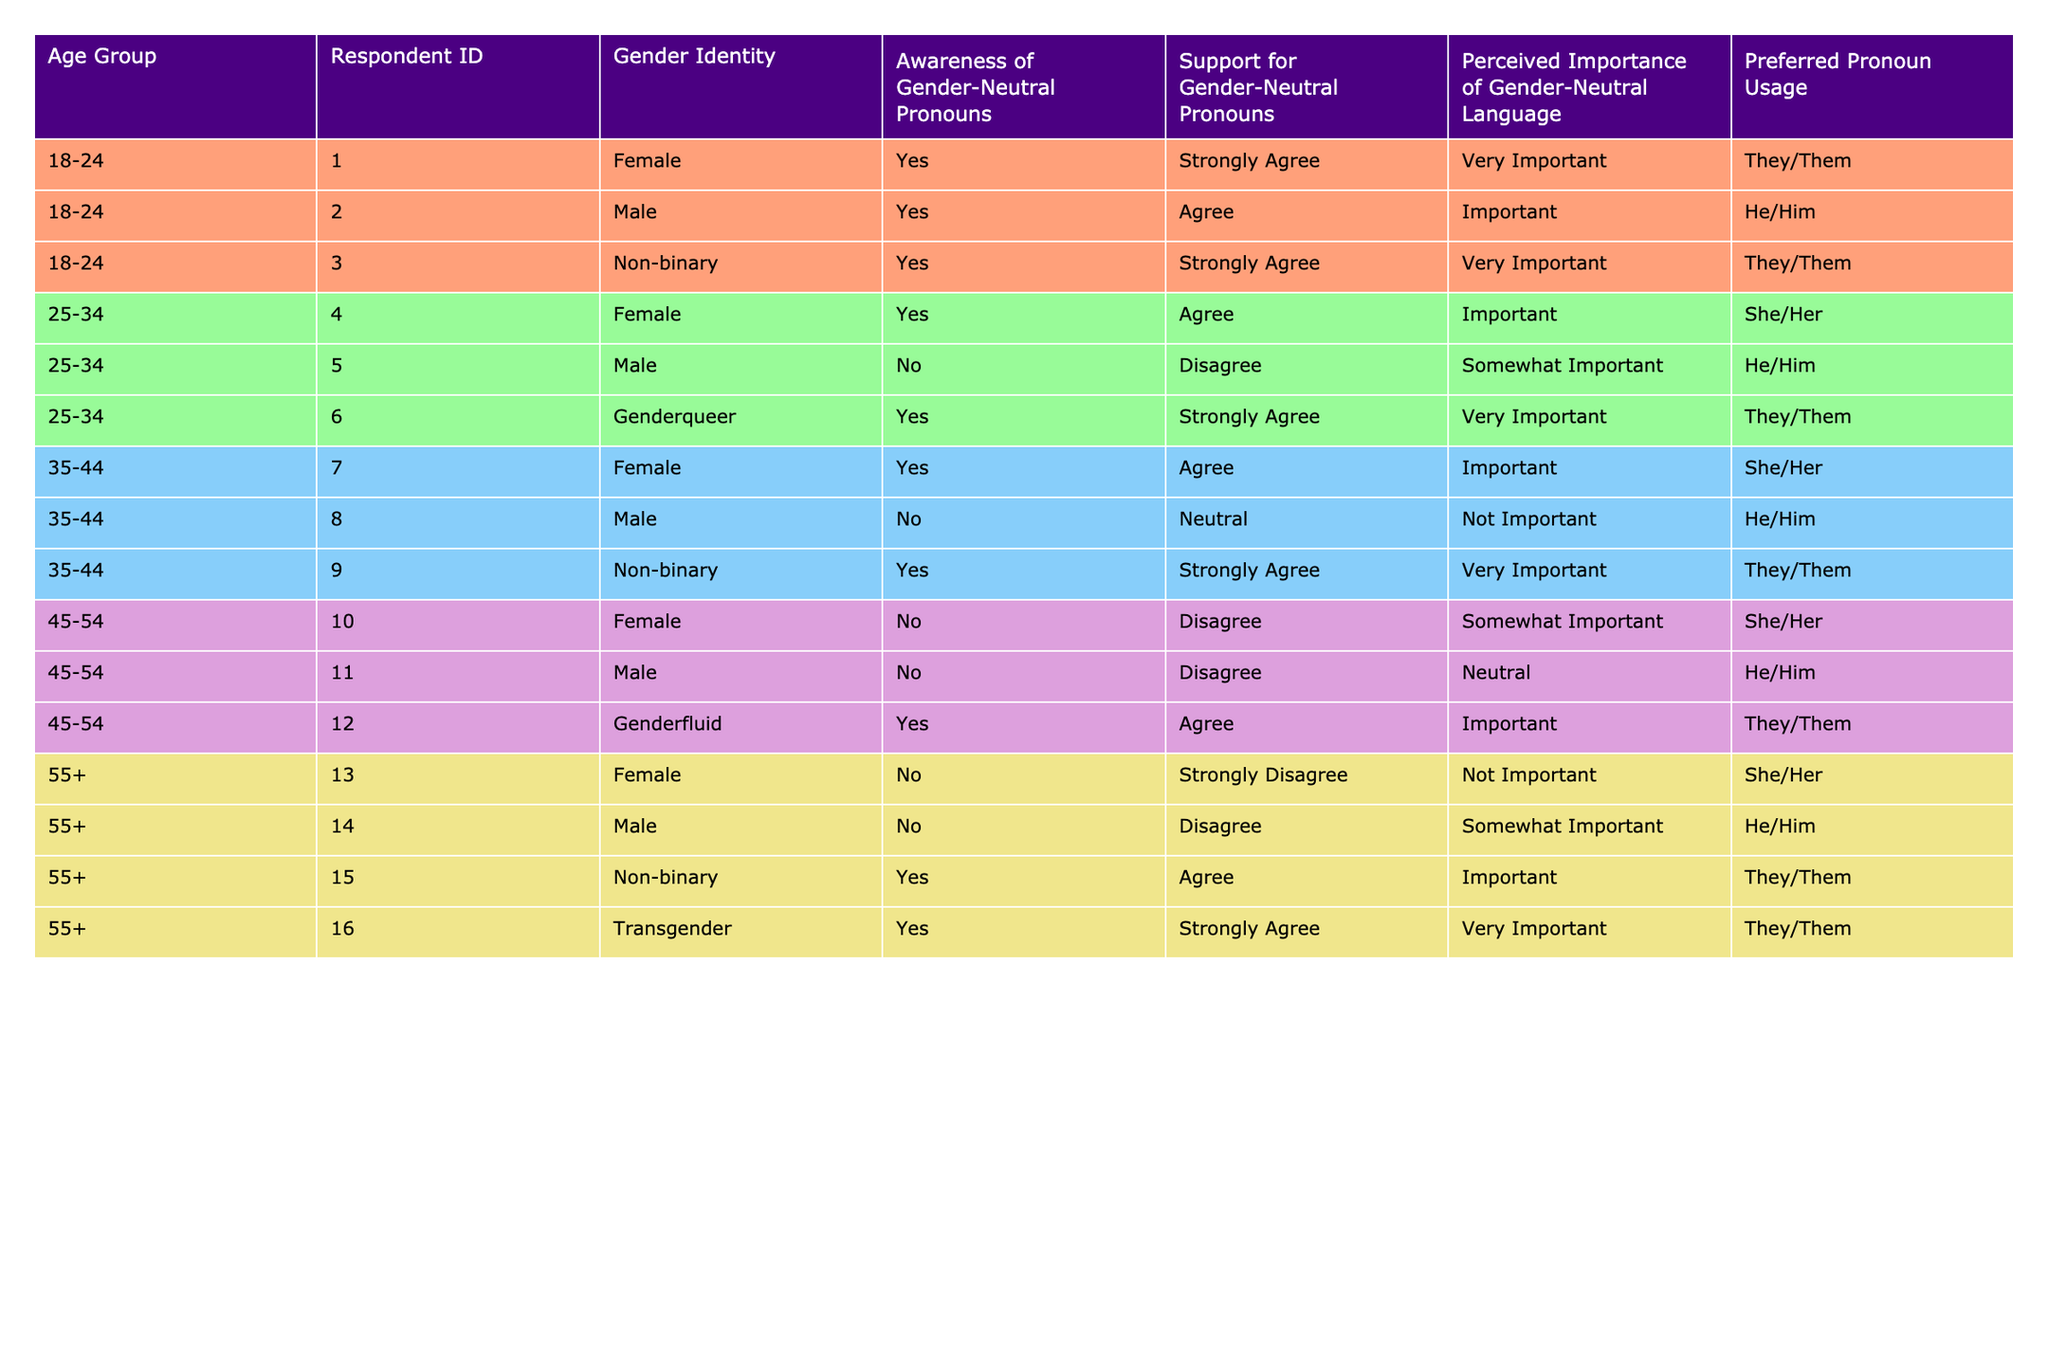What's the total number of respondents who are aware of gender-neutral pronouns? There are 8 respondents in the table who have a "Yes" response for awareness of gender-neutral pronouns, specifically found in the rows with IDs 001, 002, 003, 004, 006, 007, 009, 012, 015, and 016. Counting these, the total is 8.
Answer: 8 How many respondents aged 35-44 support gender-neutral pronouns? There are 3 respondents in the 35-44 age group. Their support levels are listed as "Agree" or "Strongly Agree." The specific IDs are 007, 009. Thus, the total is 3.
Answer: 3 What percentage of respondents in the 18-24 age group prefer the pronoun "They/Them"? Out of 3 total respondents in the 18-24 age group, 2 prefer "They/Them." The percentage is calculated as (2/3) * 100 = 66.67%.
Answer: 66.67% Are there any respondents who identify as Genderqueer and also support gender-neutral pronouns? Yes, the data shows that there is 1 respondent who identifies as Genderqueer (ID 006) and supports gender-neutral pronouns with a response of "Strongly Agree."
Answer: Yes How does the perceived importance of gender-neutral language vary across age groups? The perceived importance varies: In the 18-24 group, it's "Very Important" for 2 and "Important" for 1. In the 25-34 group, it's "Very Important" for 1 and "Important" for 2. In the 35-44 group, it's "Very Important" for 1 and "Important" for 2. For the 45-54 group, it's "Important" for 1 and the rest is less important; and in the 55+ group, "Very Important" for 1 and the rest are less significant.
Answer: Varies by age group What is the average level of support for gender-neutral pronouns among respondents aged 45-54? The support levels for the 45-54 age group are Disagree, Disagree, and Agree. To quantify: "Disagree" = 1, "Agree" = 2. There are 3 respondents leading to an average of (1 + 1 + 2) / 3 = 1.33.
Answer: 1.33 How many male respondents do not support gender-neutral pronouns? There are 2 male respondents (ID 005 and ID 008) who have indicated "Disagree" or "Neutral" as their support level for gender-neutral pronouns.
Answer: 2 Which pronoun is preferred by the largest number of respondents in the 55+ age group? In this age group, "They/Them" is preferred by 3 respondents (IDs 015 and 016). The other preferences are "She/Her" and "He/Him" but do not exceed 3.
Answer: They/Them Is there a gender identity that strongly agrees with the importance of gender-neutral language among older respondents? Yes, the Transgender respondent (ID 016) strongly agrees that gender-neutral language is "Very Important," indicating that there is support among older respondents.
Answer: Yes 